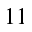Convert formula to latex. <formula><loc_0><loc_0><loc_500><loc_500>1 1</formula> 